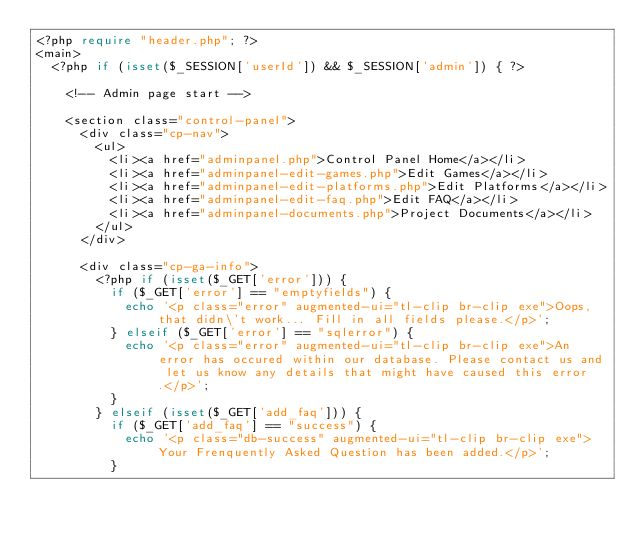Convert code to text. <code><loc_0><loc_0><loc_500><loc_500><_PHP_><?php require "header.php"; ?>
<main>
  <?php if (isset($_SESSION['userId']) && $_SESSION['admin']) { ?>

    <!-- Admin page start -->

    <section class="control-panel">
      <div class="cp-nav">
        <ul>
          <li><a href="adminpanel.php">Control Panel Home</a></li>
          <li><a href="adminpanel-edit-games.php">Edit Games</a></li>
          <li><a href="adminpanel-edit-platforms.php">Edit Platforms</a></li>
          <li><a href="adminpanel-edit-faq.php">Edit FAQ</a></li>
          <li><a href="adminpanel-documents.php">Project Documents</a></li>
        </ul>
      </div>

      <div class="cp-ga-info">
        <?php if (isset($_GET['error'])) {
          if ($_GET['error'] == "emptyfields") {
            echo '<p class="error" augmented-ui="tl-clip br-clip exe">Oops, that didn\'t work... Fill in all fields please.</p>';
          } elseif ($_GET['error'] == "sqlerror") {
            echo '<p class="error" augmented-ui="tl-clip br-clip exe">An error has occured within our database. Please contact us and let us know any details that might have caused this error.</p>';
          }
        } elseif (isset($_GET['add_faq'])) {
          if ($_GET['add_faq'] == "success") {
            echo '<p class="db-success" augmented-ui="tl-clip br-clip exe">Your Frenquently Asked Question has been added.</p>';
          }</code> 